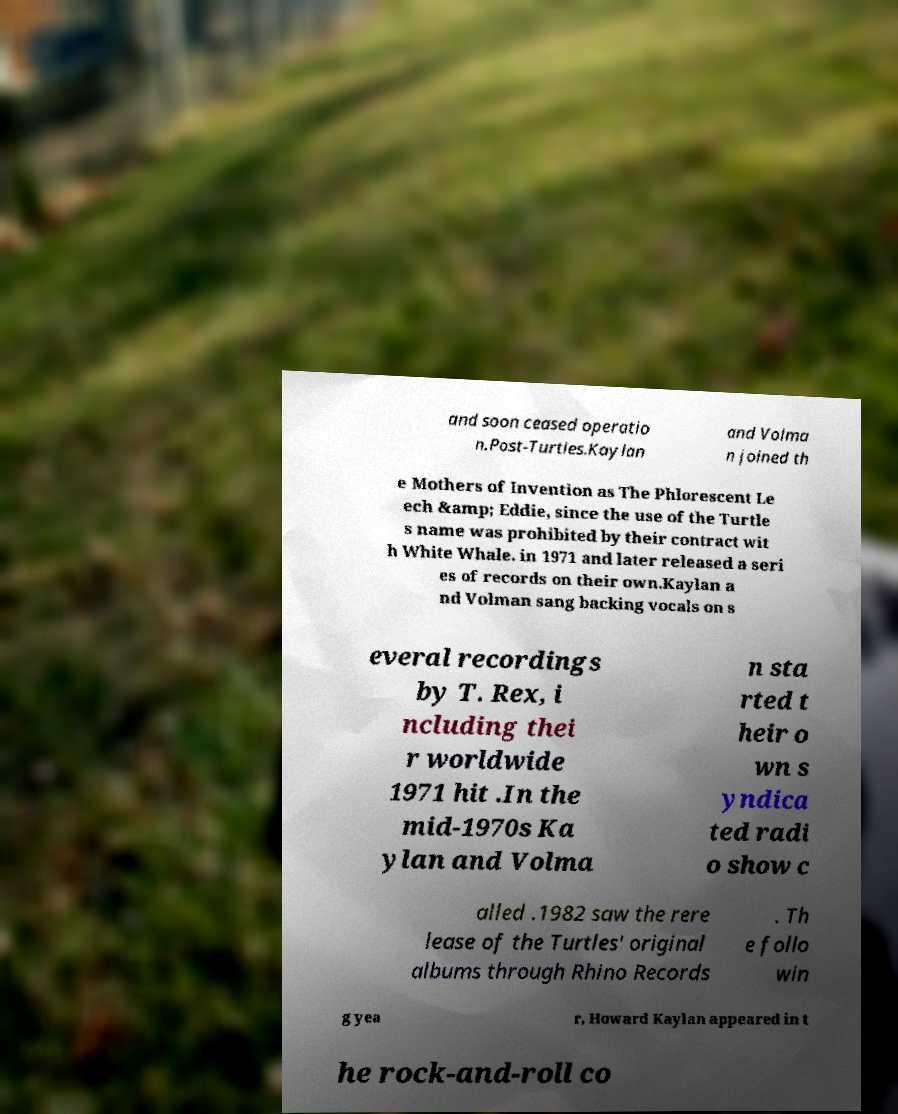What messages or text are displayed in this image? I need them in a readable, typed format. and soon ceased operatio n.Post-Turtles.Kaylan and Volma n joined th e Mothers of Invention as The Phlorescent Le ech &amp; Eddie, since the use of the Turtle s name was prohibited by their contract wit h White Whale. in 1971 and later released a seri es of records on their own.Kaylan a nd Volman sang backing vocals on s everal recordings by T. Rex, i ncluding thei r worldwide 1971 hit .In the mid-1970s Ka ylan and Volma n sta rted t heir o wn s yndica ted radi o show c alled .1982 saw the rere lease of the Turtles' original albums through Rhino Records . Th e follo win g yea r, Howard Kaylan appeared in t he rock-and-roll co 